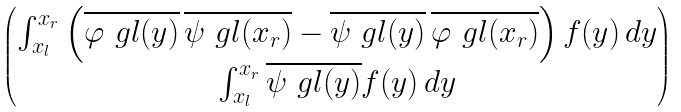Convert formula to latex. <formula><loc_0><loc_0><loc_500><loc_500>\begin{pmatrix} \int ^ { x _ { r } } _ { x _ { l } } \left ( \overline { \varphi _ { \ } g l ( y ) } \, \overline { \psi _ { \ } g l ( x _ { r } ) } - \overline { \psi _ { \ } g l ( y ) } \, \overline { \varphi _ { \ } g l ( x _ { r } ) } \right ) f ( y ) \, d y \\ \int ^ { x _ { r } } _ { x _ { l } } \overline { \psi _ { \ } g l ( y ) } f ( y ) \, d y \end{pmatrix}</formula> 